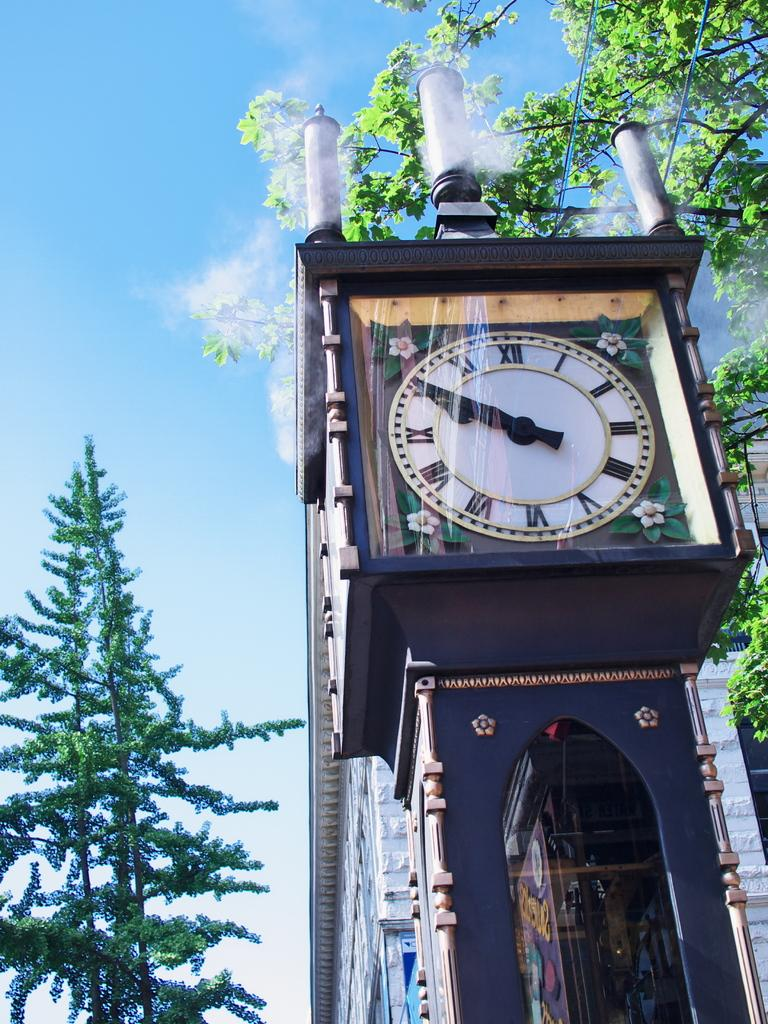<image>
Summarize the visual content of the image. Clock outdoors with the hands both on the number 10. 